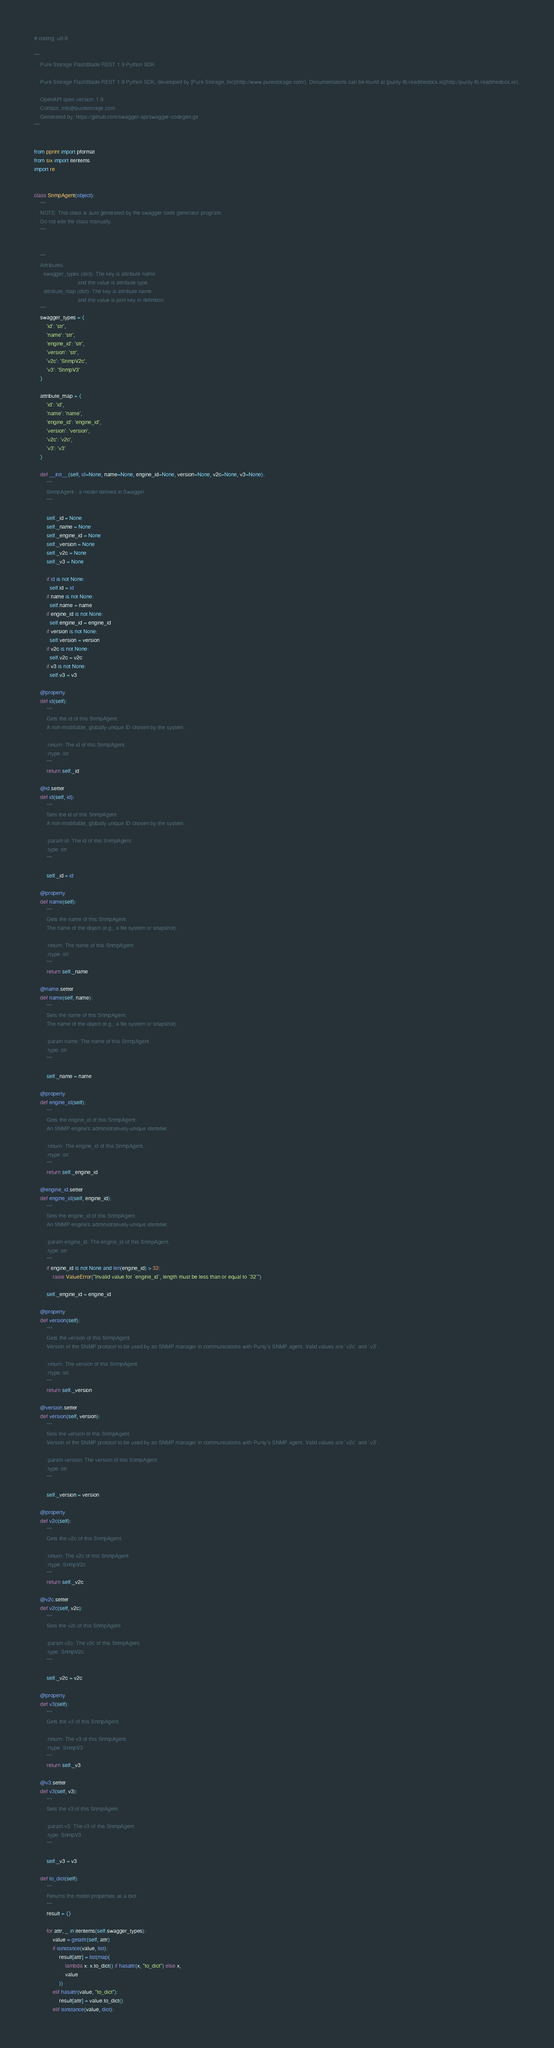Convert code to text. <code><loc_0><loc_0><loc_500><loc_500><_Python_># coding: utf-8

"""
    Pure Storage FlashBlade REST 1.9 Python SDK

    Pure Storage FlashBlade REST 1.9 Python SDK, developed by [Pure Storage, Inc](http://www.purestorage.com/). Documentations can be found at [purity-fb.readthedocs.io](http://purity-fb.readthedocs.io/).

    OpenAPI spec version: 1.9
    Contact: info@purestorage.com
    Generated by: https://github.com/swagger-api/swagger-codegen.git
"""


from pprint import pformat
from six import iteritems
import re


class SnmpAgent(object):
    """
    NOTE: This class is auto generated by the swagger code generator program.
    Do not edit the class manually.
    """


    """
    Attributes:
      swagger_types (dict): The key is attribute name
                            and the value is attribute type.
      attribute_map (dict): The key is attribute name
                            and the value is json key in definition.
    """
    swagger_types = {
        'id': 'str',
        'name': 'str',
        'engine_id': 'str',
        'version': 'str',
        'v2c': 'SnmpV2c',
        'v3': 'SnmpV3'
    }

    attribute_map = {
        'id': 'id',
        'name': 'name',
        'engine_id': 'engine_id',
        'version': 'version',
        'v2c': 'v2c',
        'v3': 'v3'
    }

    def __init__(self, id=None, name=None, engine_id=None, version=None, v2c=None, v3=None):
        """
        SnmpAgent - a model defined in Swagger
        """

        self._id = None
        self._name = None
        self._engine_id = None
        self._version = None
        self._v2c = None
        self._v3 = None

        if id is not None:
          self.id = id
        if name is not None:
          self.name = name
        if engine_id is not None:
          self.engine_id = engine_id
        if version is not None:
          self.version = version
        if v2c is not None:
          self.v2c = v2c
        if v3 is not None:
          self.v3 = v3

    @property
    def id(self):
        """
        Gets the id of this SnmpAgent.
        A non-modifiable, globally unique ID chosen by the system.

        :return: The id of this SnmpAgent.
        :rtype: str
        """
        return self._id

    @id.setter
    def id(self, id):
        """
        Sets the id of this SnmpAgent.
        A non-modifiable, globally unique ID chosen by the system.

        :param id: The id of this SnmpAgent.
        :type: str
        """

        self._id = id

    @property
    def name(self):
        """
        Gets the name of this SnmpAgent.
        The name of the object (e.g., a file system or snapshot).

        :return: The name of this SnmpAgent.
        :rtype: str
        """
        return self._name

    @name.setter
    def name(self, name):
        """
        Sets the name of this SnmpAgent.
        The name of the object (e.g., a file system or snapshot).

        :param name: The name of this SnmpAgent.
        :type: str
        """

        self._name = name

    @property
    def engine_id(self):
        """
        Gets the engine_id of this SnmpAgent.
        An SNMP engine's administratively-unique identifier.

        :return: The engine_id of this SnmpAgent.
        :rtype: str
        """
        return self._engine_id

    @engine_id.setter
    def engine_id(self, engine_id):
        """
        Sets the engine_id of this SnmpAgent.
        An SNMP engine's administratively-unique identifier.

        :param engine_id: The engine_id of this SnmpAgent.
        :type: str
        """
        if engine_id is not None and len(engine_id) > 32:
            raise ValueError("Invalid value for `engine_id`, length must be less than or equal to `32`")

        self._engine_id = engine_id

    @property
    def version(self):
        """
        Gets the version of this SnmpAgent.
        Version of the SNMP protocol to be used by an SNMP manager in communications with Purity's SNMP agent. Valid values are `v2c` and `v3`.

        :return: The version of this SnmpAgent.
        :rtype: str
        """
        return self._version

    @version.setter
    def version(self, version):
        """
        Sets the version of this SnmpAgent.
        Version of the SNMP protocol to be used by an SNMP manager in communications with Purity's SNMP agent. Valid values are `v2c` and `v3`.

        :param version: The version of this SnmpAgent.
        :type: str
        """

        self._version = version

    @property
    def v2c(self):
        """
        Gets the v2c of this SnmpAgent.

        :return: The v2c of this SnmpAgent.
        :rtype: SnmpV2c
        """
        return self._v2c

    @v2c.setter
    def v2c(self, v2c):
        """
        Sets the v2c of this SnmpAgent.

        :param v2c: The v2c of this SnmpAgent.
        :type: SnmpV2c
        """

        self._v2c = v2c

    @property
    def v3(self):
        """
        Gets the v3 of this SnmpAgent.

        :return: The v3 of this SnmpAgent.
        :rtype: SnmpV3
        """
        return self._v3

    @v3.setter
    def v3(self, v3):
        """
        Sets the v3 of this SnmpAgent.

        :param v3: The v3 of this SnmpAgent.
        :type: SnmpV3
        """

        self._v3 = v3

    def to_dict(self):
        """
        Returns the model properties as a dict
        """
        result = {}

        for attr, _ in iteritems(self.swagger_types):
            value = getattr(self, attr)
            if isinstance(value, list):
                result[attr] = list(map(
                    lambda x: x.to_dict() if hasattr(x, "to_dict") else x,
                    value
                ))
            elif hasattr(value, "to_dict"):
                result[attr] = value.to_dict()
            elif isinstance(value, dict):</code> 